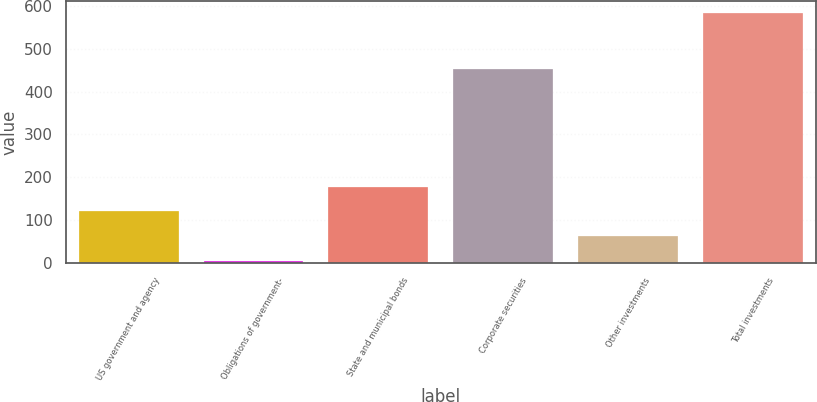Convert chart to OTSL. <chart><loc_0><loc_0><loc_500><loc_500><bar_chart><fcel>US government and agency<fcel>Obligations of government-<fcel>State and municipal bonds<fcel>Corporate securities<fcel>Other investments<fcel>Total investments<nl><fcel>120.4<fcel>5<fcel>178.1<fcel>453<fcel>62.7<fcel>582<nl></chart> 